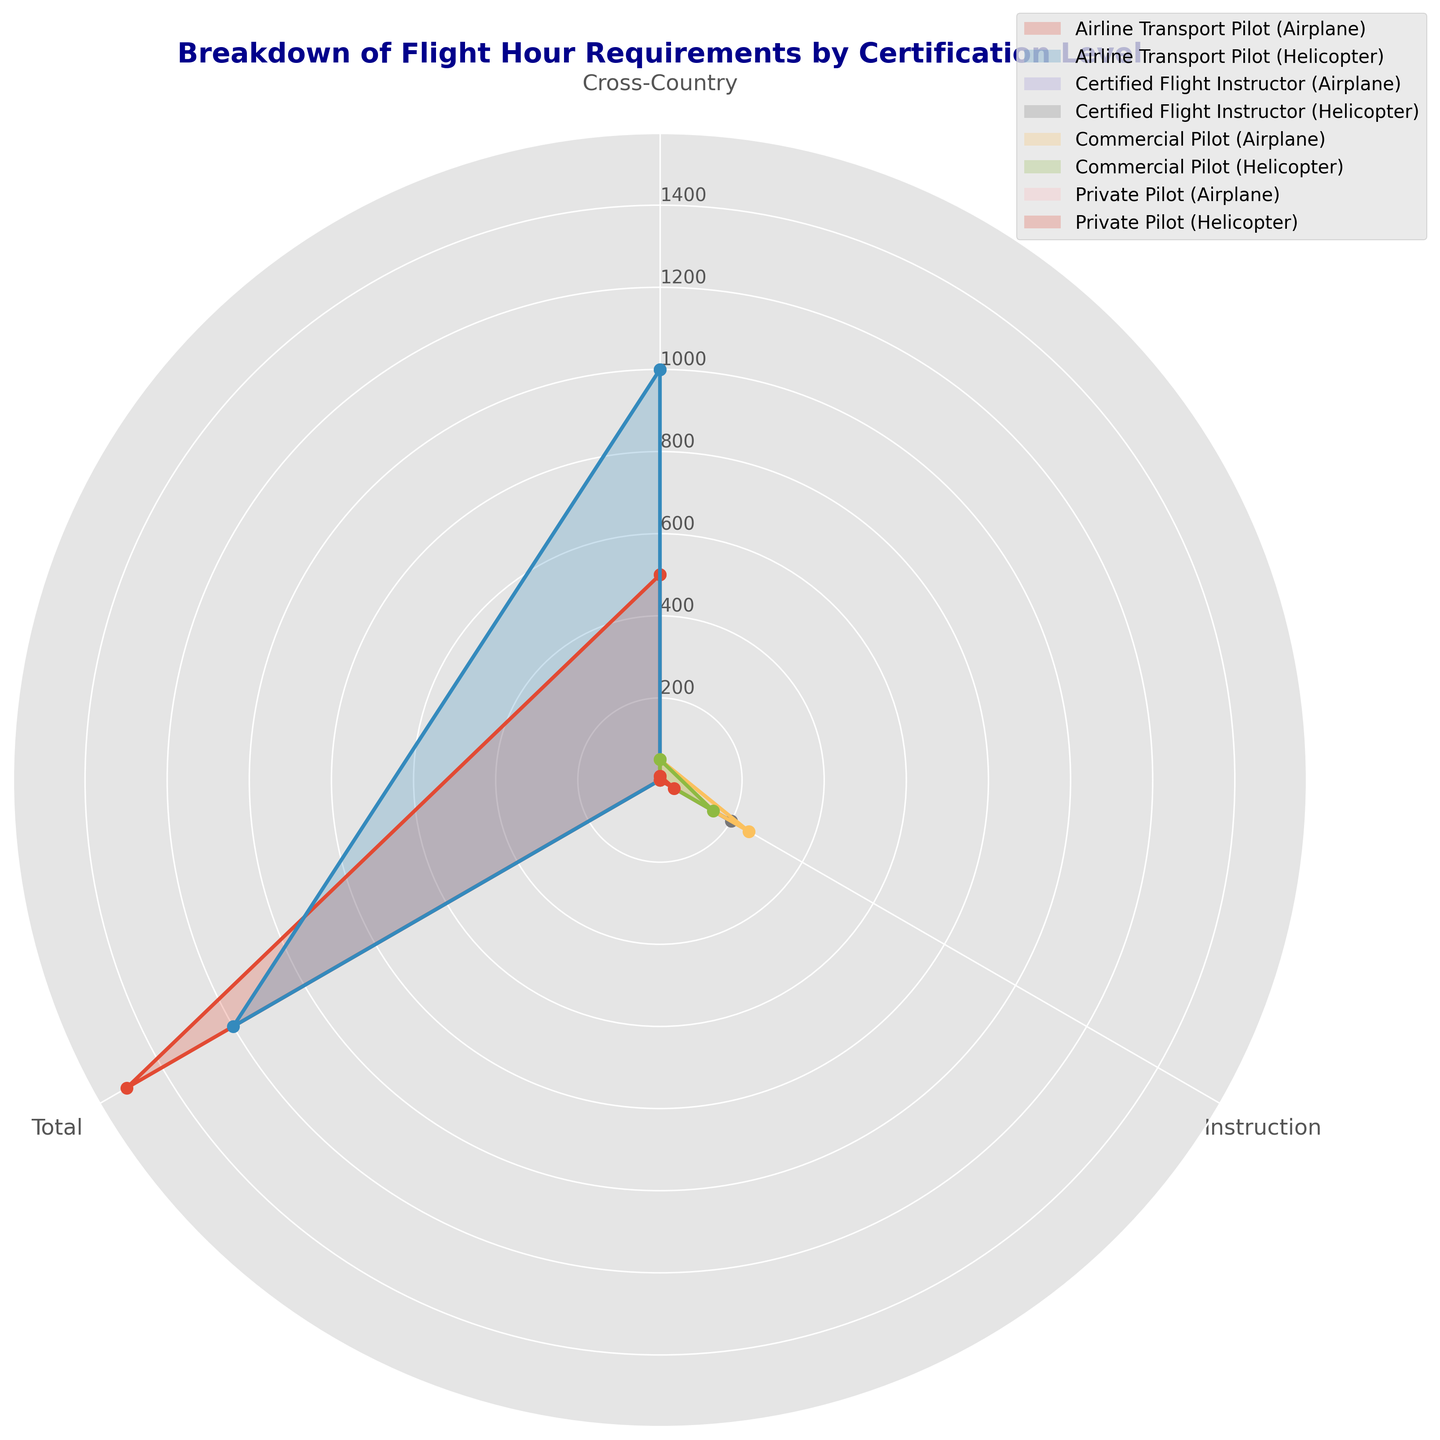Which certification level requires the most total flight hours? We look at the highest values given in the different certification levels. Airline Transport Pilot (Airplane) has the highest total flight hours (1500).
Answer: Airline Transport Pilot (Airplane) How many more total flight hours are required for an Airline Transport Pilot (Airplane) compared to an Airline Transport Pilot (Helicopter)? Compare the total flight hours required for both certification levels. Airline Transport Pilot (Airplane) has 1500 hours, whereas Airline Transport Pilot (Helicopter) has 1200 hours. The difference is 1500 - 1200 = 300.
Answer: 300 Compare the cross-country flight hours required for Commercial Pilot (Airplane) and Private Pilot (Helicopter). Which one requires more? Looking at the cross-country flight hours, Commercial Pilot (Airplane) requires 50 hours and Private Pilot (Helicopter) requires 10 hours. Commercial Pilot (Airplane) requires more.
Answer: Commercial Pilot (Airplane) Which certification requires equal flight hours for both airplanes and helicopters? Check the flight hour requirements for each certification level for both airplanes and helicopters. Certified Flight Instructor requires 200 hours for both types.
Answer: Certified Flight Instructor What is the combined cross-country flight hour requirement for an Airline Transport Pilot (Helicopter) and a Commercial Pilot (Airplane)? Sum the cross-country flight hours required for both certifications. Airline Transport Pilot (Helicopter) requires 1000 hours and Commercial Pilot (Airplane) requires 50 hours. The combined total is 1000 + 50 = 1050.
Answer: 1050 Among all the segments, which certification level has the least cross-country flight hour requirements? Look for the minimum value in cross-country flight hour requirements across all certification levels. Private Pilot (Airplane) and Private Pilot (Helicopter) both require 10 hours, which is the least.
Answer: Private Pilot (Airplane) and Private Pilot (Helicopter) What fraction of the total flight hours required for a Private Pilot (Helicopter) are dedicated to cross-country flights? Calculate the proportion of cross-country flight hours to the total flight hours. Cross-country hours are 10, and total hours are 50 (40 instruction + 10 cross-country). The fraction is 10/50 = 1/5.
Answer: 1/5 Is the instructional flight hour requirement for a Commercial Pilot (Helicopter) greater than or equal to the total hours required for a Private Pilot (Helicopter)? Compare the instructional hours of Commercial Pilot (Helicopter) with the total hours of Private Pilot (Helicopter). Commercial Pilot (Helicopter) instructional hours are 150, and the total hours required for Private Pilot (Helicopter) are 50. Since 150 > 50, it is greater.
Answer: Yes Which has more instructional flight hour requirements: a Commercial Pilot (Airplane) or a Certified Flight Instructor (Helicopter)? Compare the instructional hours for both certifications. Commercial Pilot (Airplane) requires 250 hours, whereas Certified Flight Instructor (Helicopter) requires 200 hours. Commercial Pilot (Airplane) requires more.
Answer: Commercial Pilot (Airplane) What is the total flight hour requirement for an Airline Transport Pilot (Airplane) for both total and cross-country categories? Sum the flight hours for Airline Transport Pilot (Airplane) in both categories. Total hours are 1500, and cross-country hours are 500. The sum is 1500 + 500 = 2000.
Answer: 2000 